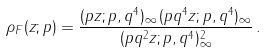Convert formula to latex. <formula><loc_0><loc_0><loc_500><loc_500>\rho _ { F } ( z ; p ) = \frac { ( p z ; p , q ^ { 4 } ) _ { \infty } \, ( p q ^ { 4 } z ; p , q ^ { 4 } ) _ { \infty } } { ( p q ^ { 2 } z ; p , q ^ { 4 } ) _ { \infty } ^ { 2 } } \, .</formula> 